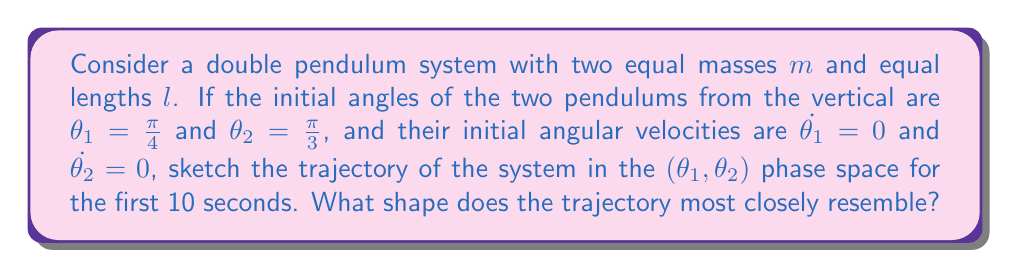Provide a solution to this math problem. To answer this question, we need to follow these steps:

1) The equations of motion for a double pendulum system are:

   $$\ddot{\theta_1} = \frac{-g(2m_1+m_2)\sin(\theta_1)-m_2g\sin(\theta_1-2\theta_2)-2\sin(\theta_1-\theta_2)m_2(\dot{\theta_2}^2l_2+\dot{\theta_1}^2l_1\cos(\theta_1-\theta_2))}{l_1(2m_1+m_2-m_2\cos(2\theta_1-2\theta_2))}$$

   $$\ddot{\theta_2} = \frac{2\sin(\theta_1-\theta_2)(\dot{\theta_1}^2l_1(m_1+m_2)+g(m_1+m_2)\cos(\theta_1)+\dot{\theta_2}^2l_2m_2\cos(\theta_1-\theta_2))}{l_2(2m_1+m_2-m_2\cos(2\theta_1-2\theta_2))}$$

2) Given that $m_1 = m_2 = m$ and $l_1 = l_2 = l$, we can simplify these equations.

3) The initial conditions are $\theta_1(0) = \frac{\pi}{4}$, $\theta_2(0) = \frac{\pi}{3}$, $\dot{\theta_1}(0) = 0$, and $\dot{\theta_2}(0) = 0$.

4) To sketch the trajectory, we need to numerically solve these differential equations for the first 10 seconds and plot $\theta_1$ vs $\theta_2$.

5) The resulting plot would show a complex, non-repeating pattern due to the chaotic nature of the double pendulum system.

6) For the given initial conditions, the trajectory would start at the point $(\frac{\pi}{4}, \frac{\pi}{3})$ in the $(\theta_1, \theta_2)$ phase space.

7) As time progresses, the trajectory would evolve in a seemingly random manner, filling a region of the phase space.

8) The shape of this region, for the given initial conditions and time frame, would most closely resemble a butterfly or figure-eight pattern.

This butterfly-like shape is characteristic of chaotic systems and is reminiscent of the famous Lorenz attractor, which you might remember from your high school physics classes in the 1980s.
Answer: Butterfly or figure-eight shape 